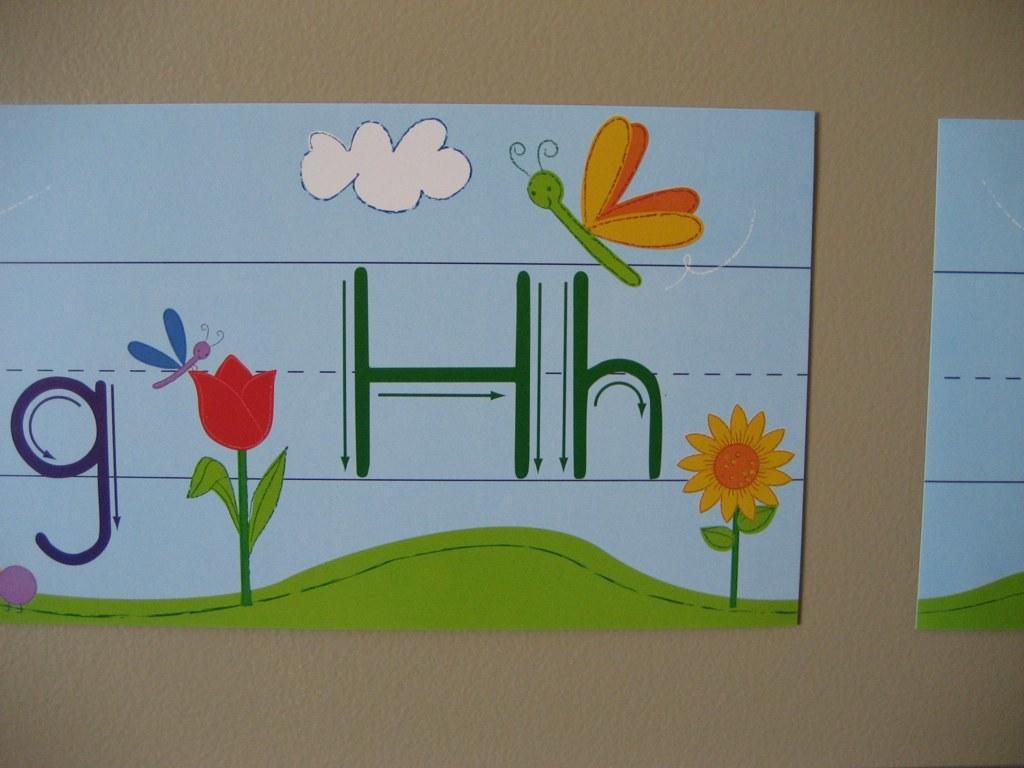Please provide a concise description of this image. In this image, these look like the boards with the colorful painting and letters on it. I think these boards are attached to the wall. 